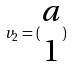<formula> <loc_0><loc_0><loc_500><loc_500>v _ { 2 } = ( \begin{matrix} a \\ 1 \end{matrix} )</formula> 